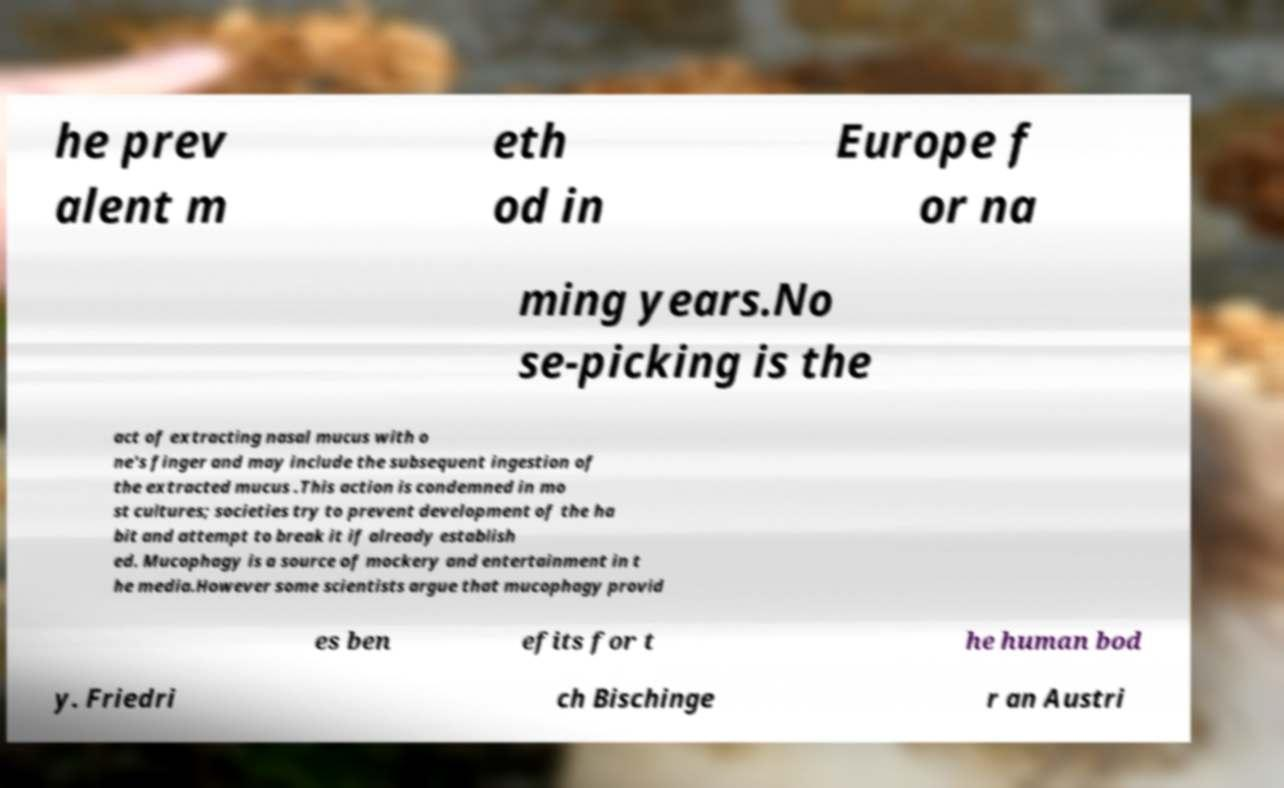Could you assist in decoding the text presented in this image and type it out clearly? he prev alent m eth od in Europe f or na ming years.No se-picking is the act of extracting nasal mucus with o ne's finger and may include the subsequent ingestion of the extracted mucus .This action is condemned in mo st cultures; societies try to prevent development of the ha bit and attempt to break it if already establish ed. Mucophagy is a source of mockery and entertainment in t he media.However some scientists argue that mucophagy provid es ben efits for t he human bod y. Friedri ch Bischinge r an Austri 